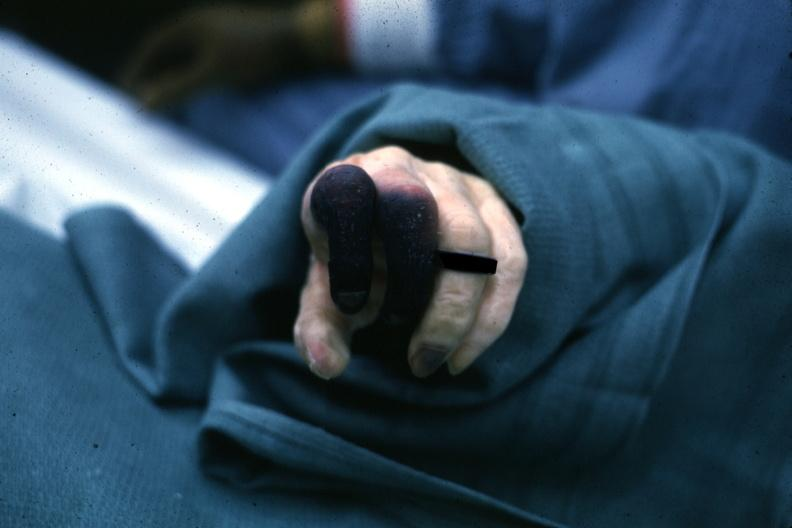re renal polycystic disease legs present?
Answer the question using a single word or phrase. No 